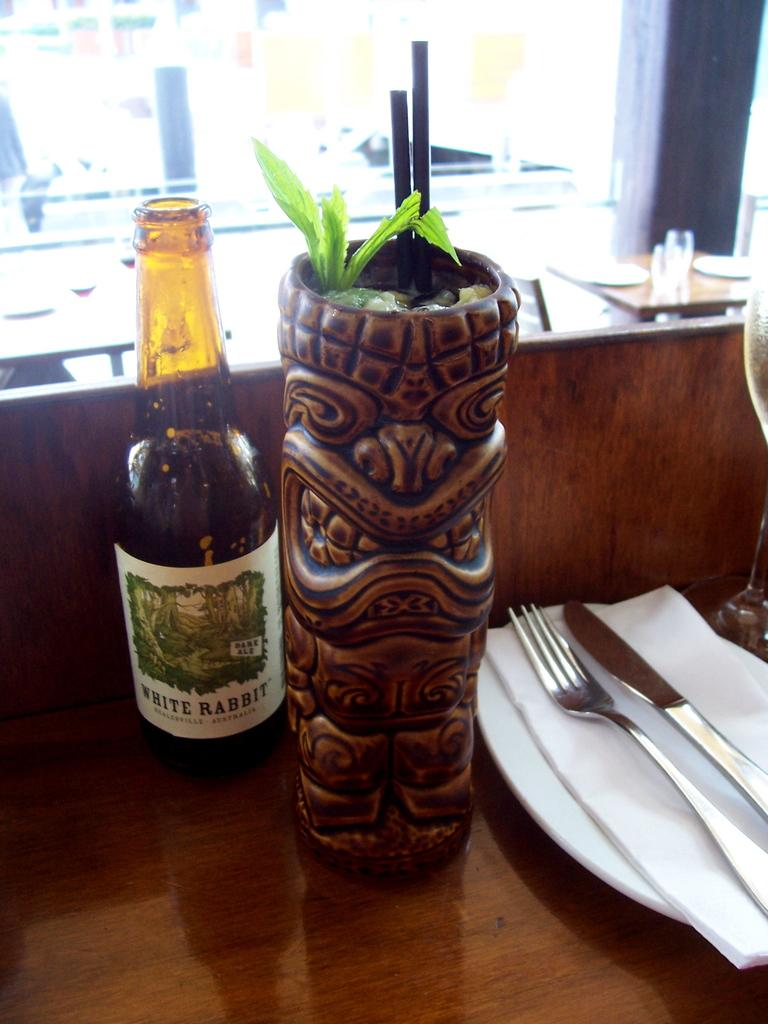<image>
Give a short and clear explanation of the subsequent image. Bottle of white rabbit mixed drink with two straws inside it. 